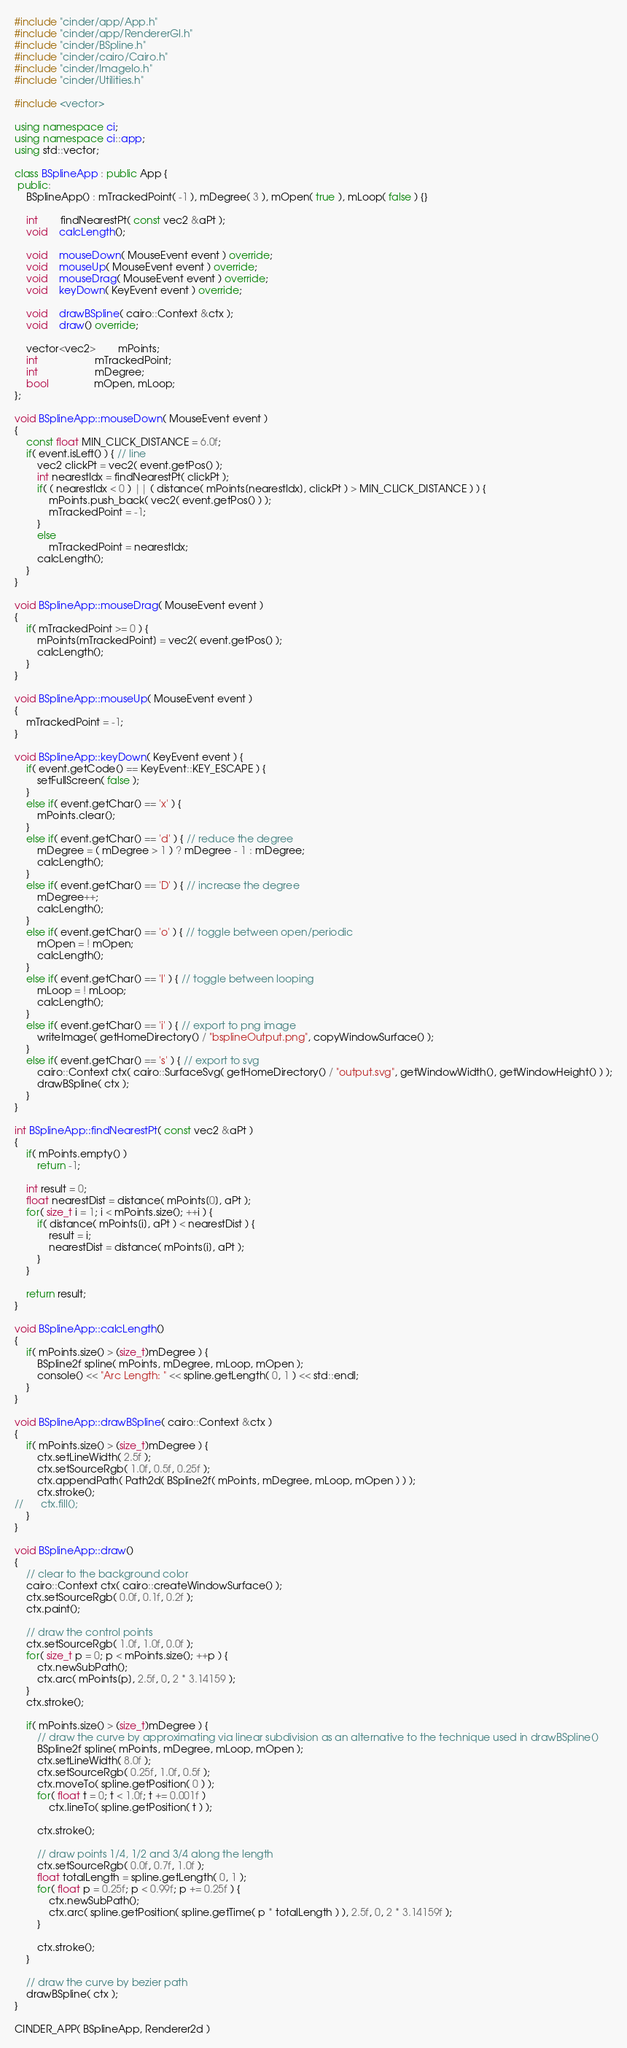<code> <loc_0><loc_0><loc_500><loc_500><_C++_>#include "cinder/app/App.h"
#include "cinder/app/RendererGl.h"
#include "cinder/BSpline.h"
#include "cinder/cairo/Cairo.h"
#include "cinder/ImageIo.h"
#include "cinder/Utilities.h"

#include <vector>

using namespace ci;
using namespace ci::app;
using std::vector;

class BSplineApp : public App {
 public:
	BSplineApp() : mTrackedPoint( -1 ), mDegree( 3 ), mOpen( true ), mLoop( false ) {}
	
	int		findNearestPt( const vec2 &aPt );
	void	calcLength();
	
	void	mouseDown( MouseEvent event ) override;
	void	mouseUp( MouseEvent event ) override;
	void	mouseDrag( MouseEvent event ) override;
	void	keyDown( KeyEvent event ) override;

	void	drawBSpline( cairo::Context &ctx );
	void	draw() override;

	vector<vec2>		mPoints;
	int					mTrackedPoint;
	int					mDegree;
	bool				mOpen, mLoop;
};

void BSplineApp::mouseDown( MouseEvent event )
{
	const float MIN_CLICK_DISTANCE = 6.0f;
	if( event.isLeft() ) { // line
		vec2 clickPt = vec2( event.getPos() );
		int nearestIdx = findNearestPt( clickPt );
		if( ( nearestIdx < 0 ) || ( distance( mPoints[nearestIdx], clickPt ) > MIN_CLICK_DISTANCE ) ) {
			mPoints.push_back( vec2( event.getPos() ) );
			mTrackedPoint = -1;
		}
		else
			mTrackedPoint = nearestIdx;
		calcLength();
	}
}

void BSplineApp::mouseDrag( MouseEvent event )
{
	if( mTrackedPoint >= 0 ) {
		mPoints[mTrackedPoint] = vec2( event.getPos() );
		calcLength();
	}
}

void BSplineApp::mouseUp( MouseEvent event )
{
	mTrackedPoint = -1;
}

void BSplineApp::keyDown( KeyEvent event ) {
	if( event.getCode() == KeyEvent::KEY_ESCAPE ) {
		setFullScreen( false );
	}
	else if( event.getChar() == 'x' ) {
		mPoints.clear();
	}
	else if( event.getChar() == 'd' ) { // reduce the degree
		mDegree = ( mDegree > 1 ) ? mDegree - 1 : mDegree;
		calcLength();
	}
	else if( event.getChar() == 'D' ) { // increase the degree
		mDegree++;
		calcLength();
	}
	else if( event.getChar() == 'o' ) { // toggle between open/periodic
		mOpen = ! mOpen;
		calcLength();
	}
	else if( event.getChar() == 'l' ) { // toggle between looping
		mLoop = ! mLoop;
		calcLength();
	}
	else if( event.getChar() == 'i' ) { // export to png image
		writeImage( getHomeDirectory() / "bsplineOutput.png", copyWindowSurface() );
	}
	else if( event.getChar() == 's' ) { // export to svg
		cairo::Context ctx( cairo::SurfaceSvg( getHomeDirectory() / "output.svg", getWindowWidth(), getWindowHeight() ) );
		drawBSpline( ctx );
	}
}

int BSplineApp::findNearestPt( const vec2 &aPt )
{
	if( mPoints.empty() )
		return -1;
	
	int result = 0;
	float nearestDist = distance( mPoints[0], aPt );
	for( size_t i = 1; i < mPoints.size(); ++i ) {
		if( distance( mPoints[i], aPt ) < nearestDist ) {
			result = i;
			nearestDist = distance( mPoints[i], aPt );
		}
	}
	
	return result;
}

void BSplineApp::calcLength()
{
	if( mPoints.size() > (size_t)mDegree ) {
		BSpline2f spline( mPoints, mDegree, mLoop, mOpen );
		console() << "Arc Length: " << spline.getLength( 0, 1 ) << std::endl;
	}
}

void BSplineApp::drawBSpline( cairo::Context &ctx )
{
	if( mPoints.size() > (size_t)mDegree ) {
		ctx.setLineWidth( 2.5f );
		ctx.setSourceRgb( 1.0f, 0.5f, 0.25f );
		ctx.appendPath( Path2d( BSpline2f( mPoints, mDegree, mLoop, mOpen ) ) );
		ctx.stroke();
//		ctx.fill();
	}
}

void BSplineApp::draw()
{
	// clear to the background color
	cairo::Context ctx( cairo::createWindowSurface() );
	ctx.setSourceRgb( 0.0f, 0.1f, 0.2f );
	ctx.paint();
	
	// draw the control points
	ctx.setSourceRgb( 1.0f, 1.0f, 0.0f );
	for( size_t p = 0; p < mPoints.size(); ++p ) {
		ctx.newSubPath();
		ctx.arc( mPoints[p], 2.5f, 0, 2 * 3.14159 );
	}
	ctx.stroke();

	if( mPoints.size() > (size_t)mDegree ) {
		// draw the curve by approximating via linear subdivision as an alternative to the technique used in drawBSpline()
		BSpline2f spline( mPoints, mDegree, mLoop, mOpen );
		ctx.setLineWidth( 8.0f );
		ctx.setSourceRgb( 0.25f, 1.0f, 0.5f );
		ctx.moveTo( spline.getPosition( 0 ) );
		for( float t = 0; t < 1.0f; t += 0.001f )
			ctx.lineTo( spline.getPosition( t ) );
		
		ctx.stroke();
		
		// draw points 1/4, 1/2 and 3/4 along the length
		ctx.setSourceRgb( 0.0f, 0.7f, 1.0f );
		float totalLength = spline.getLength( 0, 1 );
		for( float p = 0.25f; p < 0.99f; p += 0.25f ) {
			ctx.newSubPath();
			ctx.arc( spline.getPosition( spline.getTime( p * totalLength ) ), 2.5f, 0, 2 * 3.14159f );
		}		
		
		ctx.stroke();
	}

	// draw the curve by bezier path
	drawBSpline( ctx );	
}

CINDER_APP( BSplineApp, Renderer2d )</code> 